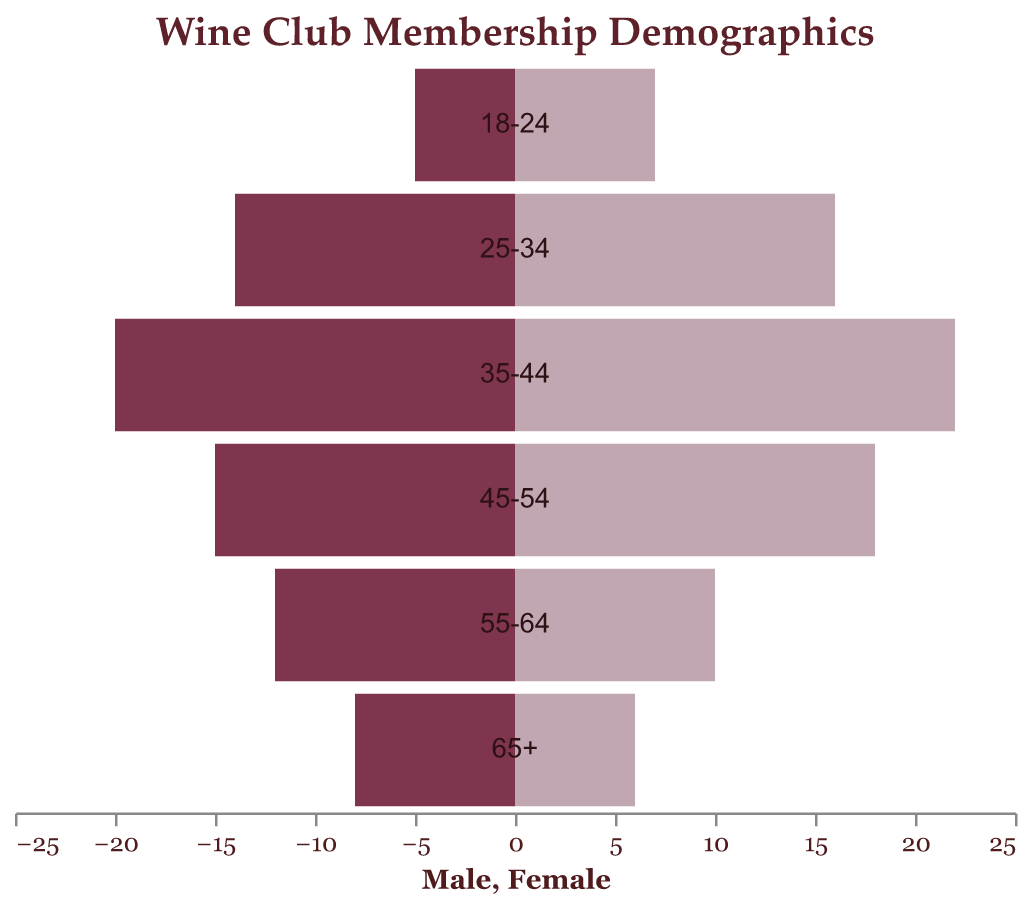What's the title of the figure? The title of the figure is typically found at the top and serves to summarize the main point of the data visualization. In this case, the title reads "Wine Club Membership Demographics"
Answer: Wine Club Membership Demographics Which age group has the highest number of male members? To identify the age group with the highest number of male members, compare the Male values across all age groups. The highest value appears in the 35-44 age group with 20 male members.
Answer: 35-44 How many female members are there in the 25-34 age group? To find the number of female members in the 25-34 age group, locate that age group and refer to the corresponding Female value.
Answer: 16 In which age group is the difference between male and female members the largest? Calculate the absolute differences between male and female members for each age group: 65+ (2), 55-64 (2), 45-54 (3), 35-44 (2), 25-34 (2), 18-24 (2). The largest difference is in the 45-54 age group.
Answer: 45-54 What is the total number of members in the 18-24 age group? Sum the number of males and females in the 18-24 age group: 5 (Male) + 7 (Female) = 12.
Answer: 12 Compare the number of female members in the 45-54 age group to the number of male members in the same group. Which gender has more members? In the 45-54 age group, there are 15 males and 18 females. Compare these values to see that females outnumber males.
Answer: Females Which age group has an equal number of male and female members? Check if there are any age groups where the number of male members matches the number of female members. None of the age groups have an equal number of male and female members.
Answer: None What is the combined total of male and female members in the 35-44 and 25-34 age groups? Add the number of male and female members in both age groups: (35-44: 20 Male + 22 Female) + (25-34: 14 Male + 16 Female) = 72.
Answer: 72 Are there more male members in the 55-64 age group than female members in the 65+ age group? Compare the number of male members in the 55-64 age group (12) with the number of female members in the 65+ age group (6).
Answer: Yes 